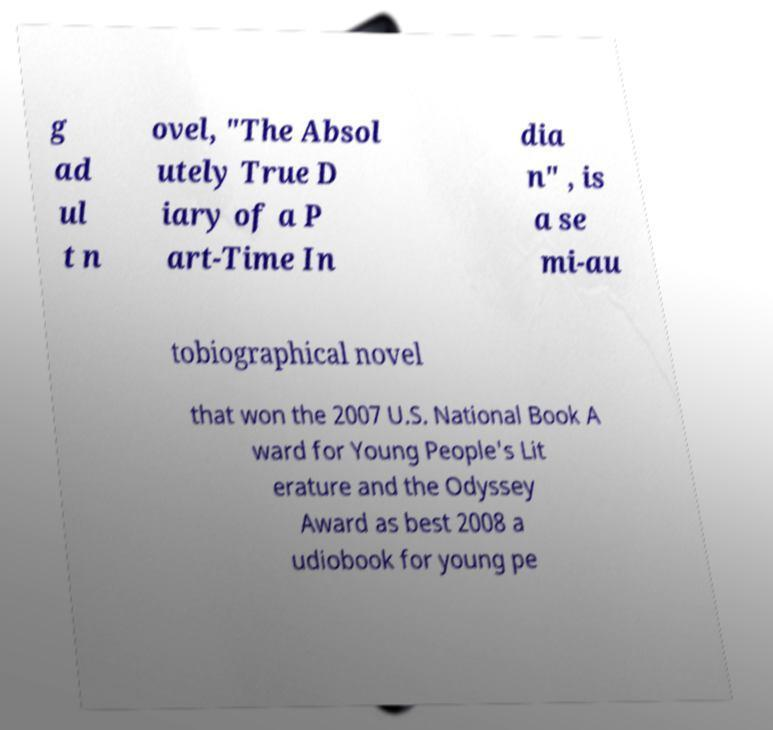Could you assist in decoding the text presented in this image and type it out clearly? g ad ul t n ovel, "The Absol utely True D iary of a P art-Time In dia n" , is a se mi-au tobiographical novel that won the 2007 U.S. National Book A ward for Young People's Lit erature and the Odyssey Award as best 2008 a udiobook for young pe 